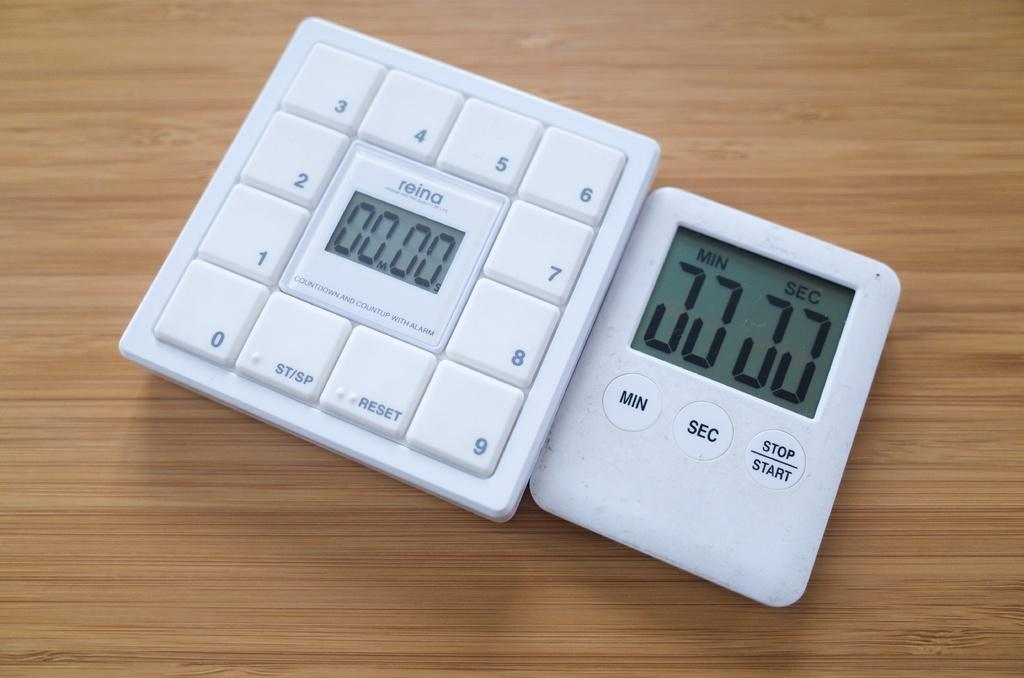<image>
Present a compact description of the photo's key features. A Reina brand electronic device that reads zero minutes and zero seconds. 